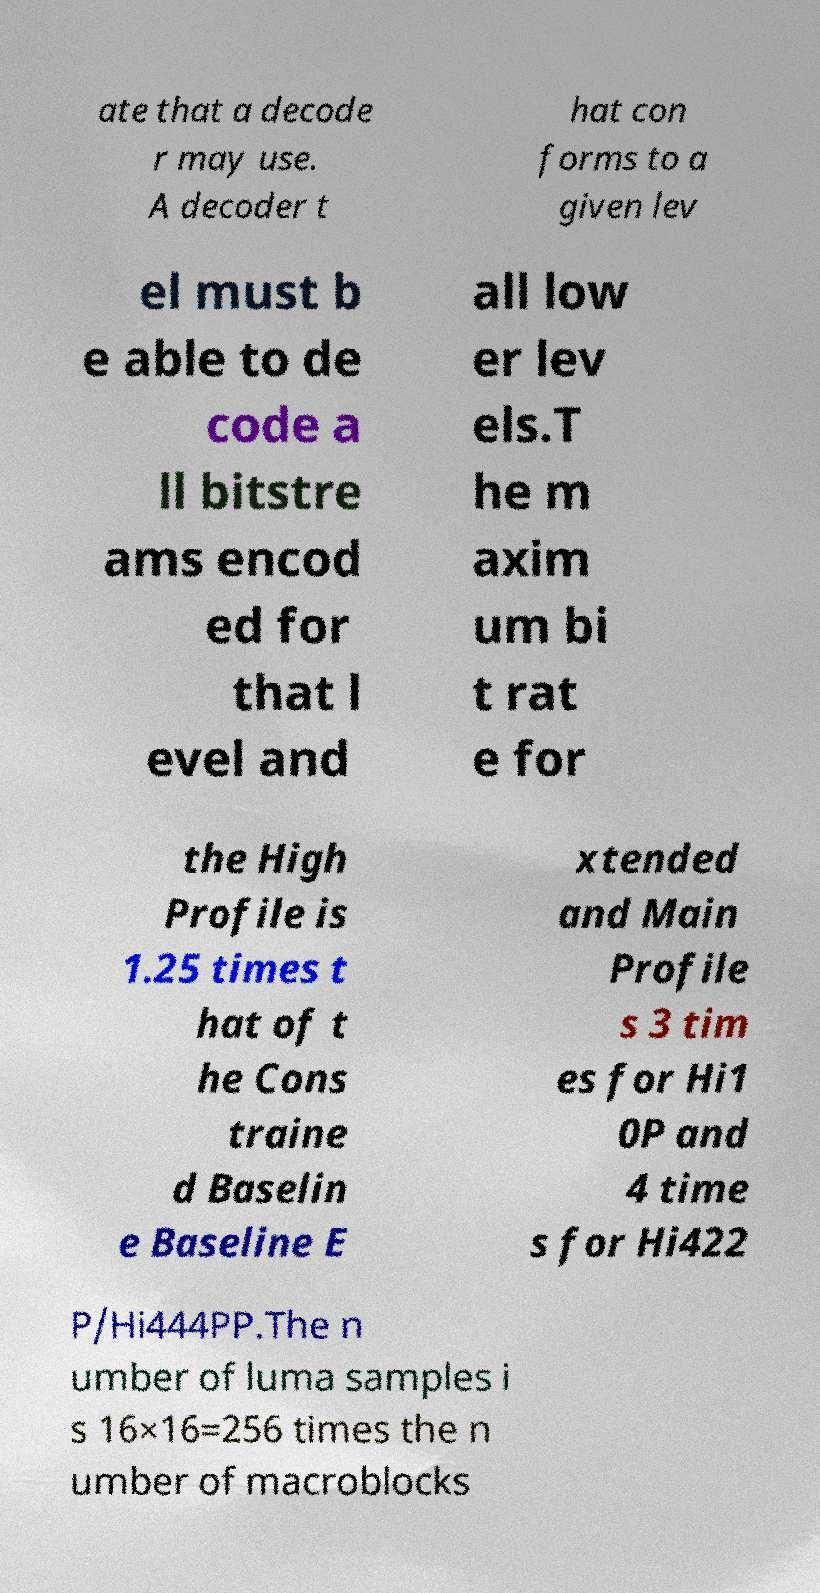Can you accurately transcribe the text from the provided image for me? ate that a decode r may use. A decoder t hat con forms to a given lev el must b e able to de code a ll bitstre ams encod ed for that l evel and all low er lev els.T he m axim um bi t rat e for the High Profile is 1.25 times t hat of t he Cons traine d Baselin e Baseline E xtended and Main Profile s 3 tim es for Hi1 0P and 4 time s for Hi422 P/Hi444PP.The n umber of luma samples i s 16×16=256 times the n umber of macroblocks 